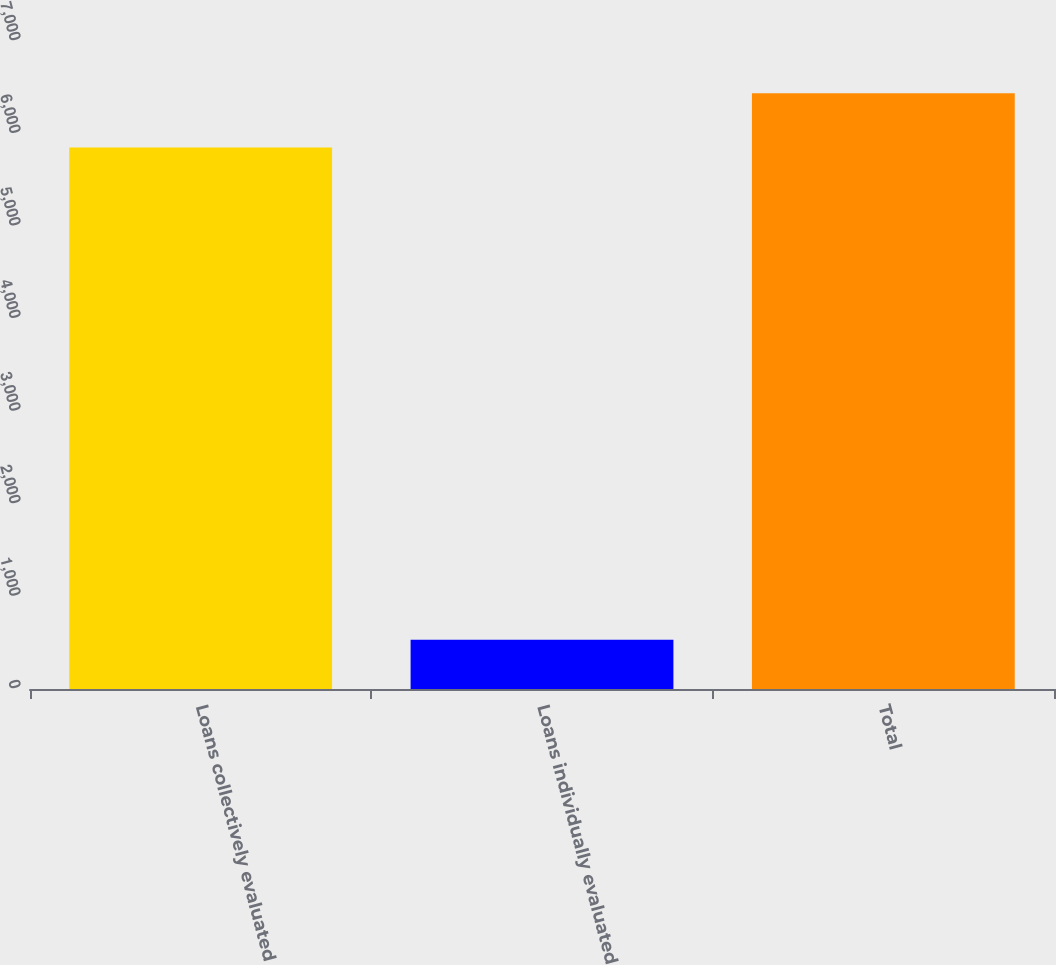<chart> <loc_0><loc_0><loc_500><loc_500><bar_chart><fcel>Loans collectively evaluated<fcel>Loans individually evaluated<fcel>Total<nl><fcel>5850<fcel>533<fcel>6435<nl></chart> 